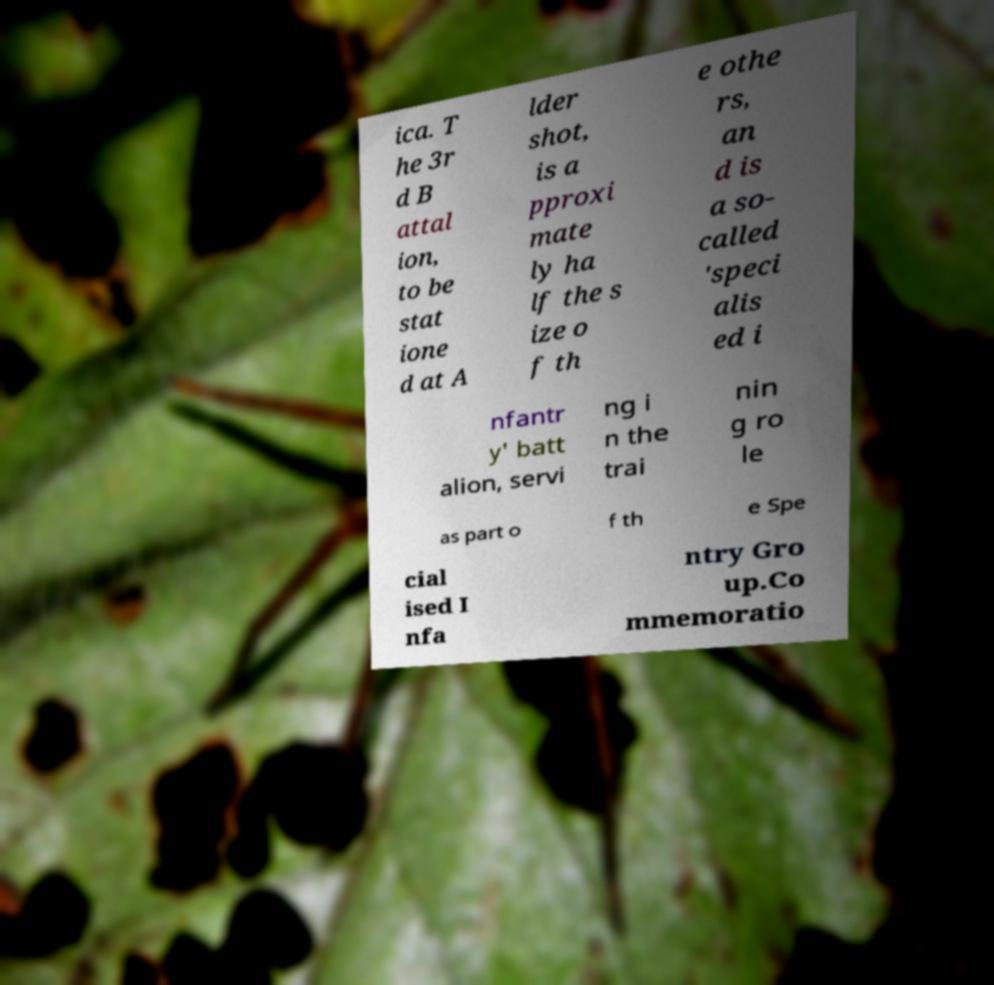There's text embedded in this image that I need extracted. Can you transcribe it verbatim? ica. T he 3r d B attal ion, to be stat ione d at A lder shot, is a pproxi mate ly ha lf the s ize o f th e othe rs, an d is a so- called 'speci alis ed i nfantr y' batt alion, servi ng i n the trai nin g ro le as part o f th e Spe cial ised I nfa ntry Gro up.Co mmemoratio 